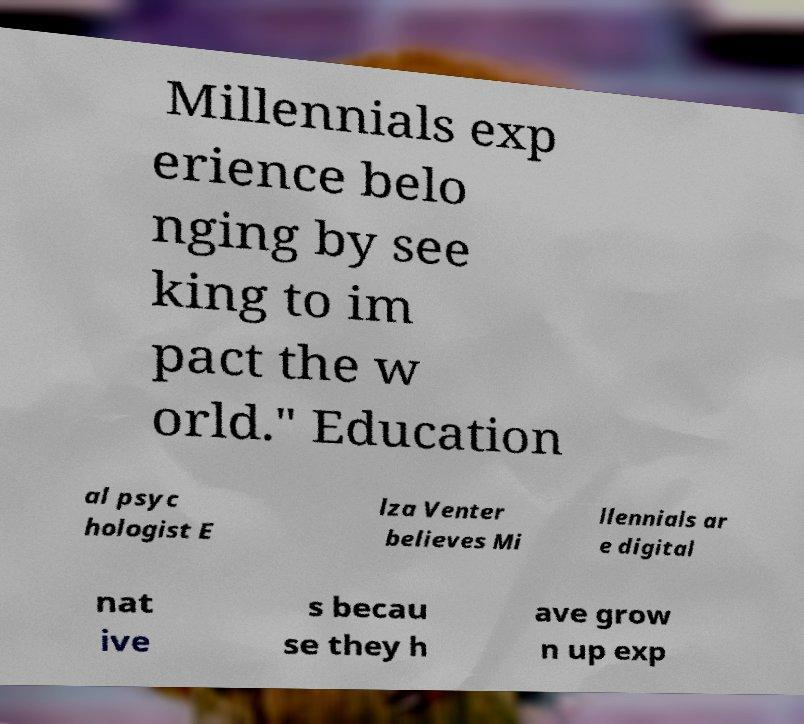Could you assist in decoding the text presented in this image and type it out clearly? Millennials exp erience belo nging by see king to im pact the w orld." Education al psyc hologist E lza Venter believes Mi llennials ar e digital nat ive s becau se they h ave grow n up exp 